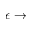<formula> <loc_0><loc_0><loc_500><loc_500>\epsilon \to</formula> 